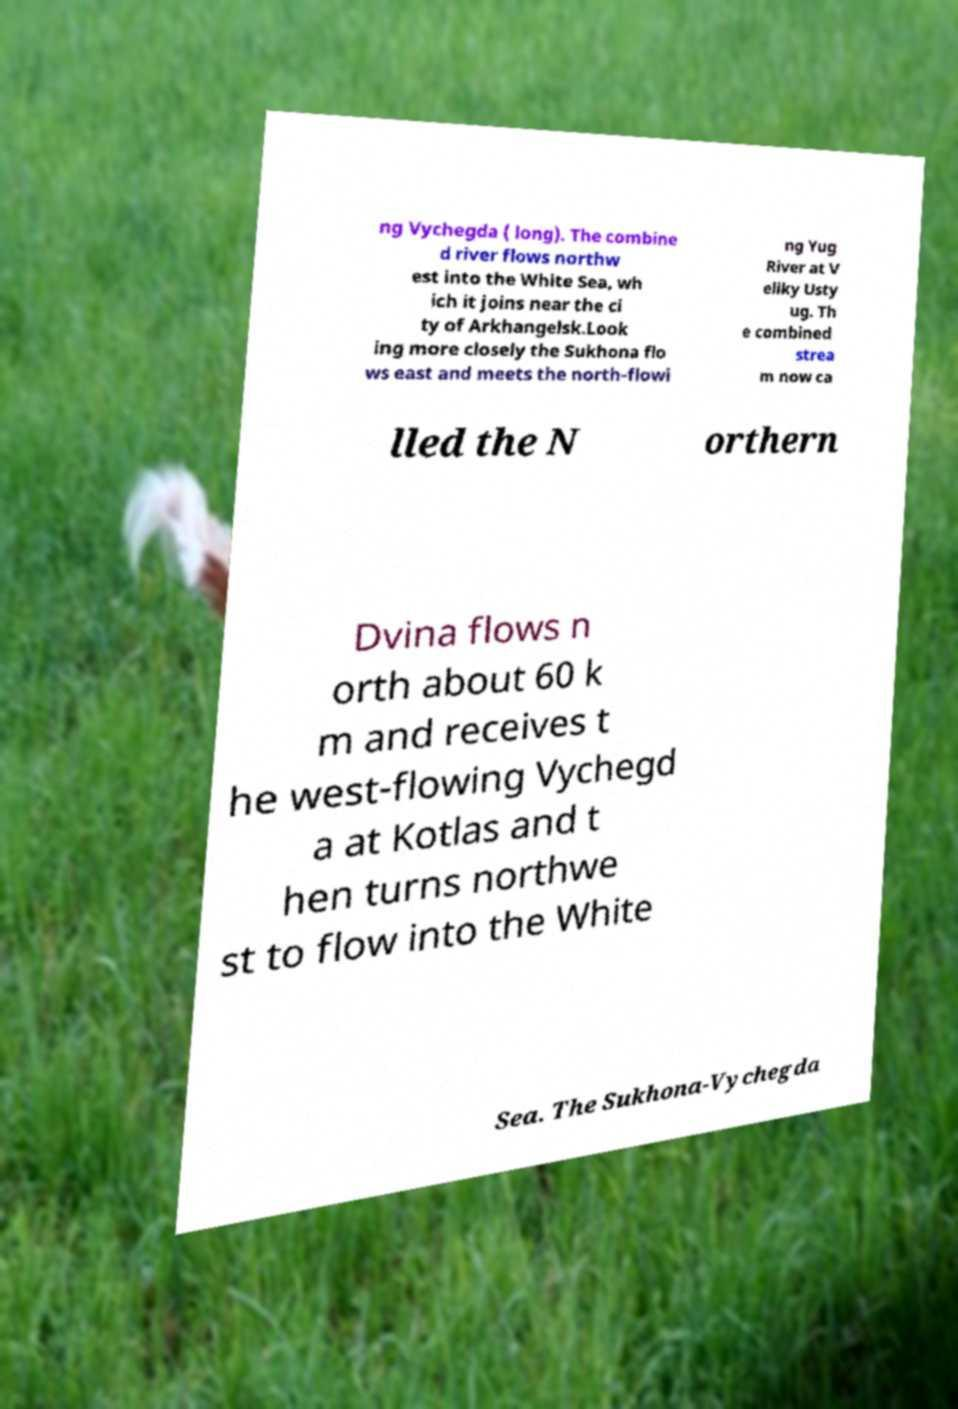I need the written content from this picture converted into text. Can you do that? ng Vychegda ( long). The combine d river flows northw est into the White Sea, wh ich it joins near the ci ty of Arkhangelsk.Look ing more closely the Sukhona flo ws east and meets the north-flowi ng Yug River at V eliky Usty ug. Th e combined strea m now ca lled the N orthern Dvina flows n orth about 60 k m and receives t he west-flowing Vychegd a at Kotlas and t hen turns northwe st to flow into the White Sea. The Sukhona-Vychegda 